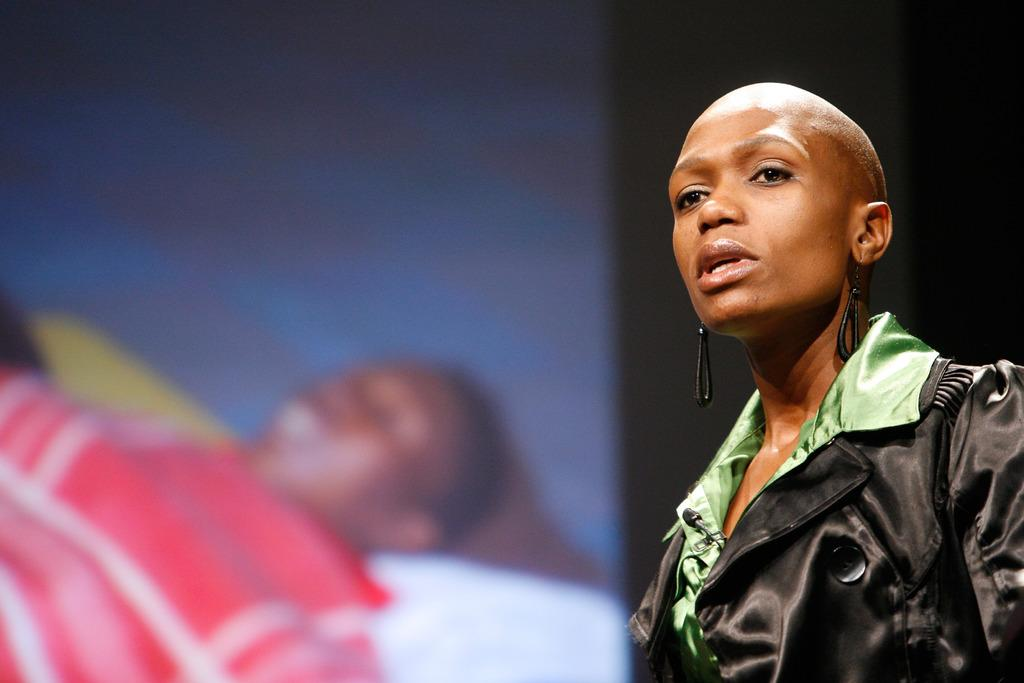What is the main activity of the person in the image? There is a person standing and talking in the image. What is the other person in the image doing? There is a person sleeping on a surface in the image. How would you describe the color scheme of the background in the image? The background of the image is black and white in color. What type of yarn is being offered to the person sleeping in the image? There is no yarn present in the image, and no one is offering anything to the person sleeping. 